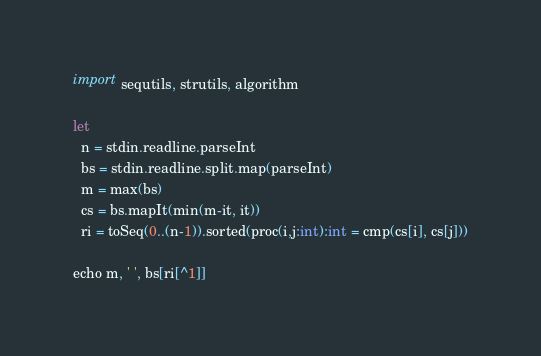<code> <loc_0><loc_0><loc_500><loc_500><_Nim_>import sequtils, strutils, algorithm

let
  n = stdin.readline.parseInt
  bs = stdin.readline.split.map(parseInt)
  m = max(bs)
  cs = bs.mapIt(min(m-it, it))
  ri = toSeq(0..(n-1)).sorted(proc(i,j:int):int = cmp(cs[i], cs[j]))

echo m, ' ', bs[ri[^1]]
</code> 